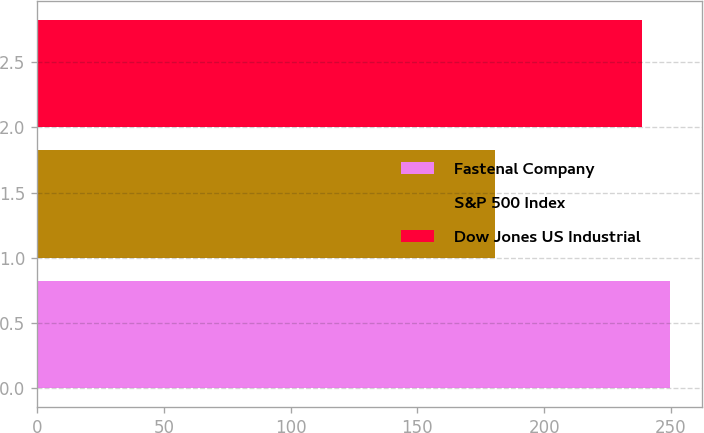Convert chart to OTSL. <chart><loc_0><loc_0><loc_500><loc_500><bar_chart><fcel>Fastenal Company<fcel>S&P 500 Index<fcel>Dow Jones US Industrial<nl><fcel>249.84<fcel>180.44<fcel>238.54<nl></chart> 